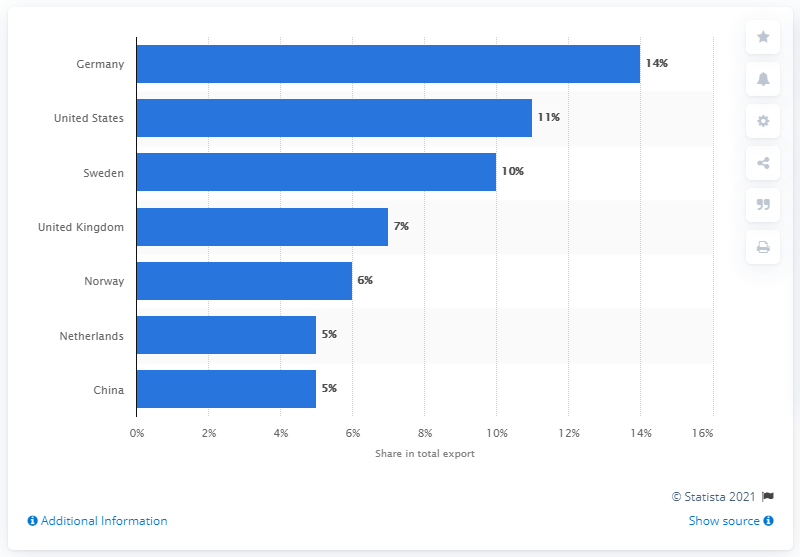Draw attention to some important aspects in this diagram. In 2019, Denmark's most important export partner was Germany. 